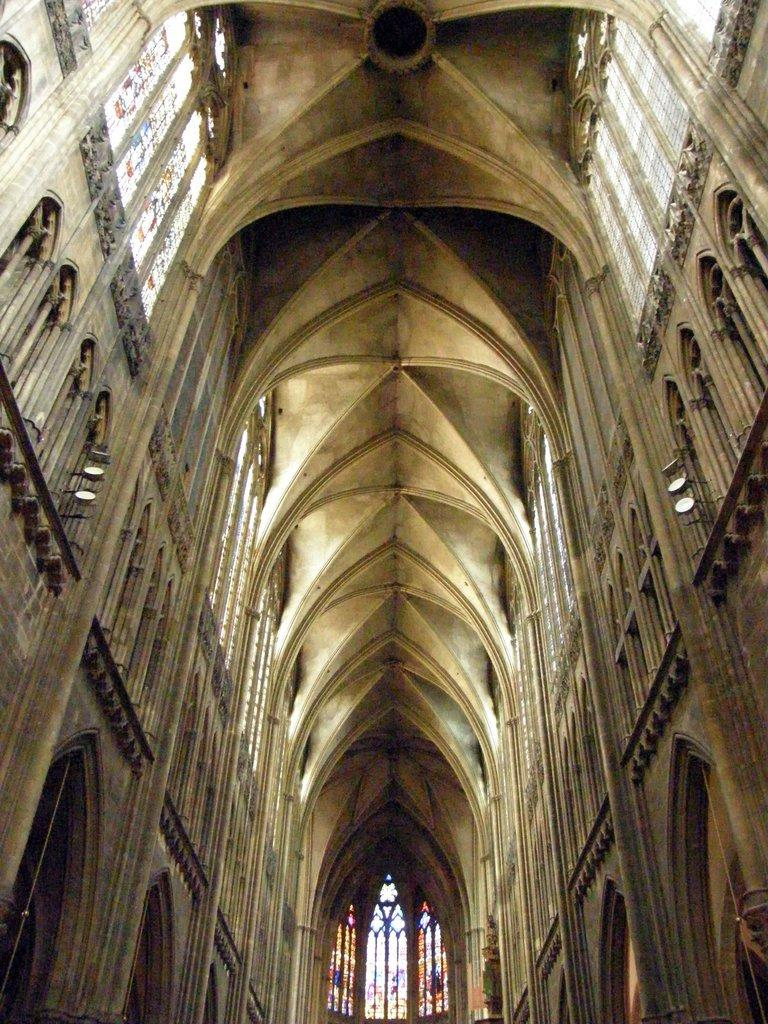What type of openings can be seen in the image? There are windows and doors in the image. What can be found in the image that provides illumination? There are lights in the image. What type of structure is visible in the image? There is a wall in the image. Is there a carpenter working on the wall in the image? There is no carpenter present in the image. What type of attraction can be seen in the image? There is no attraction present in the image; it features windows, doors, lights, and a wall. 